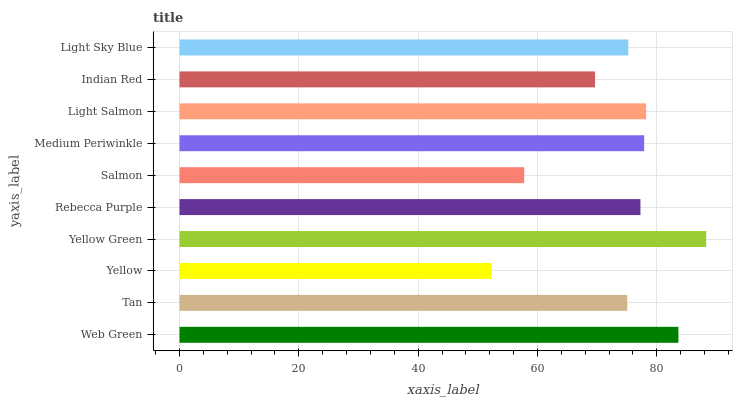Is Yellow the minimum?
Answer yes or no. Yes. Is Yellow Green the maximum?
Answer yes or no. Yes. Is Tan the minimum?
Answer yes or no. No. Is Tan the maximum?
Answer yes or no. No. Is Web Green greater than Tan?
Answer yes or no. Yes. Is Tan less than Web Green?
Answer yes or no. Yes. Is Tan greater than Web Green?
Answer yes or no. No. Is Web Green less than Tan?
Answer yes or no. No. Is Rebecca Purple the high median?
Answer yes or no. Yes. Is Light Sky Blue the low median?
Answer yes or no. Yes. Is Light Salmon the high median?
Answer yes or no. No. Is Indian Red the low median?
Answer yes or no. No. 